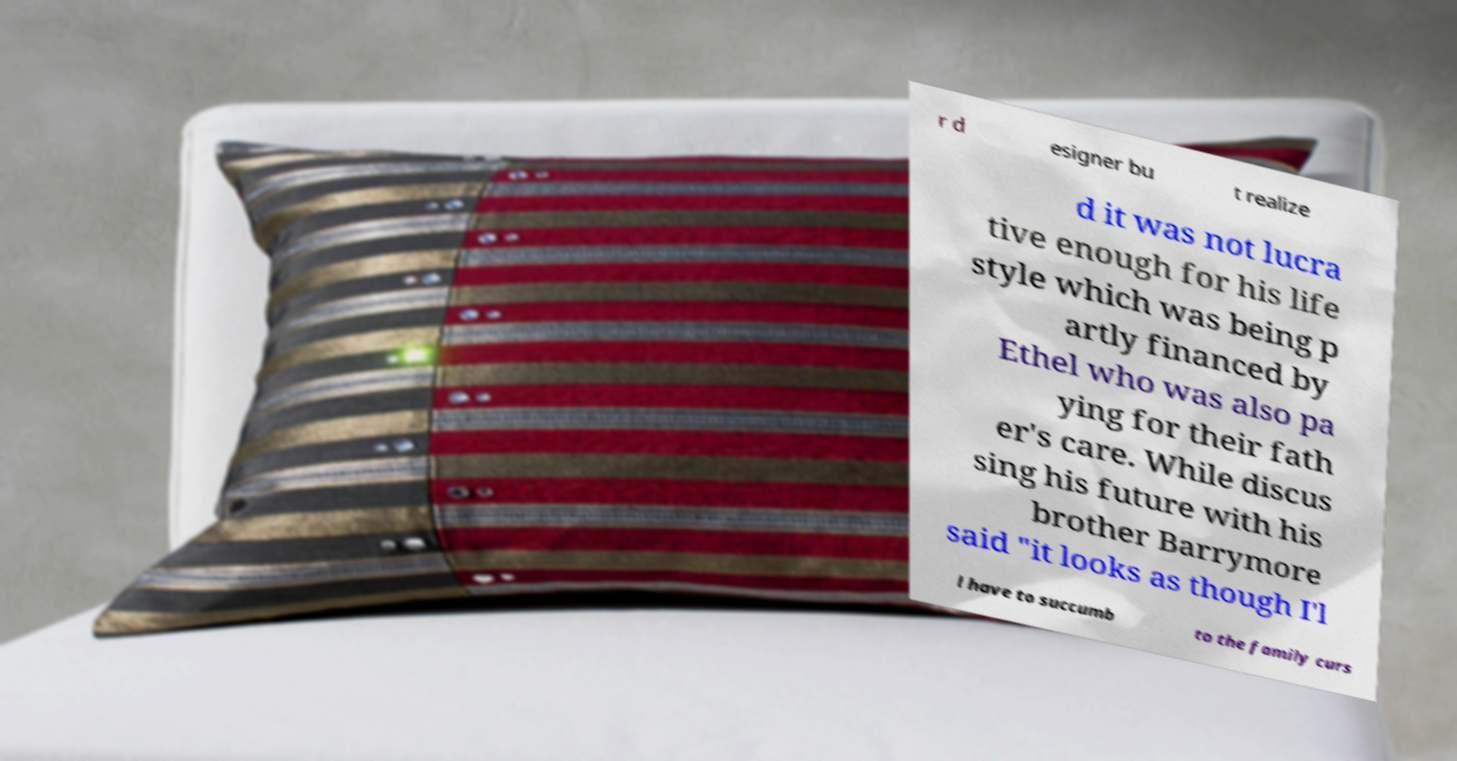There's text embedded in this image that I need extracted. Can you transcribe it verbatim? r d esigner bu t realize d it was not lucra tive enough for his life style which was being p artly financed by Ethel who was also pa ying for their fath er's care. While discus sing his future with his brother Barrymore said "it looks as though I'l l have to succumb to the family curs 